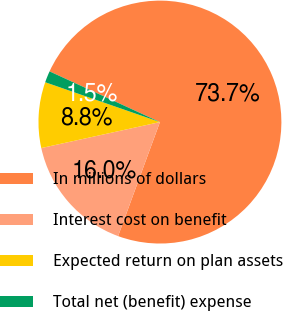Convert chart. <chart><loc_0><loc_0><loc_500><loc_500><pie_chart><fcel>In millions of dollars<fcel>Interest cost on benefit<fcel>Expected return on plan assets<fcel>Total net (benefit) expense<nl><fcel>73.74%<fcel>15.97%<fcel>8.75%<fcel>1.53%<nl></chart> 